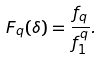<formula> <loc_0><loc_0><loc_500><loc_500>F _ { q } ( \delta ) = \frac { f _ { q } } { f _ { 1 } ^ { q } } .</formula> 